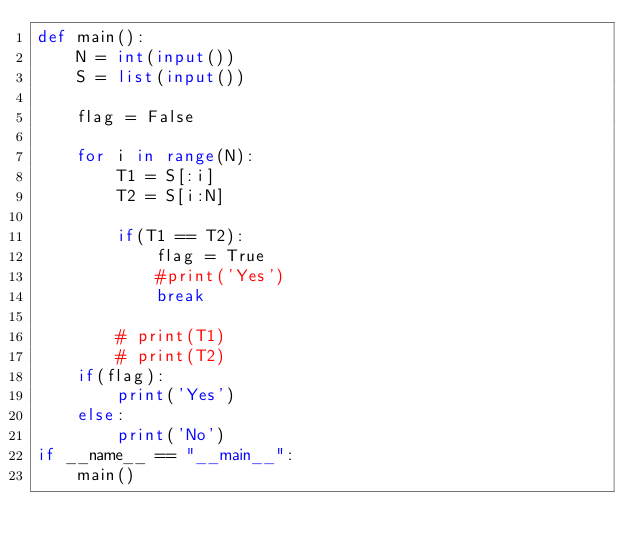Convert code to text. <code><loc_0><loc_0><loc_500><loc_500><_Python_>def main():
    N = int(input())
    S = list(input())

    flag = False

    for i in range(N):
        T1 = S[:i]
        T2 = S[i:N]

        if(T1 == T2):
            flag = True
            #print('Yes')
            break

        # print(T1)
        # print(T2)
    if(flag):
        print('Yes')
    else:
        print('No')
if __name__ == "__main__":
    main()</code> 